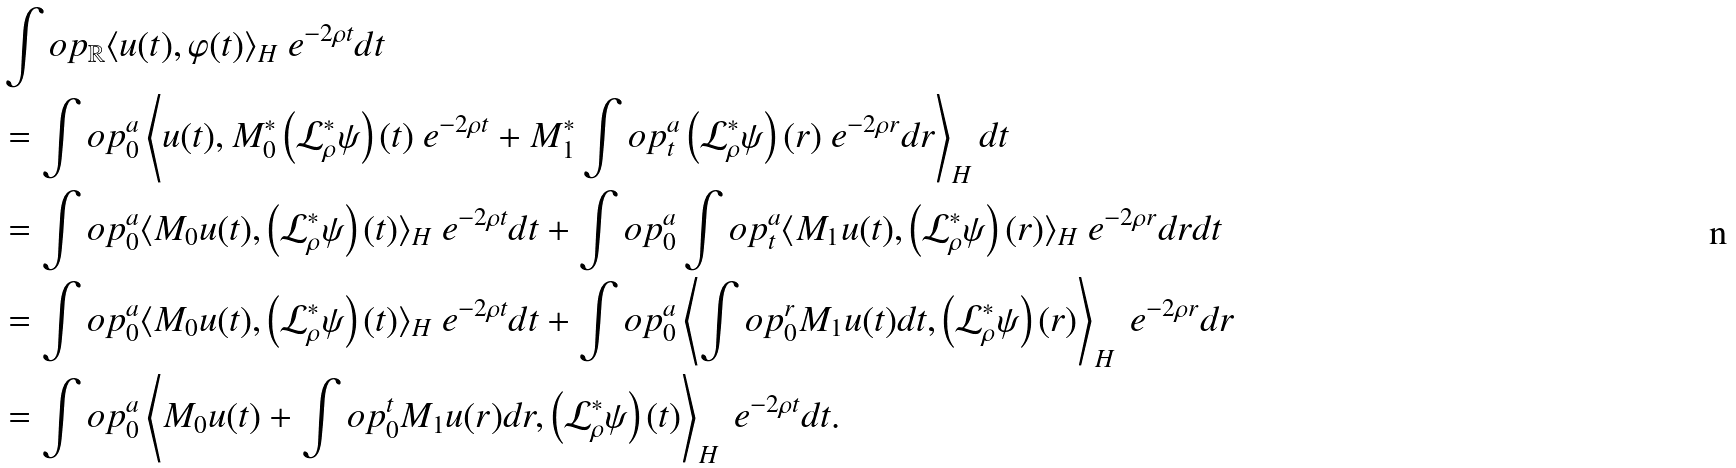Convert formula to latex. <formula><loc_0><loc_0><loc_500><loc_500>& \int o p _ { \mathbb { R } } \langle u ( t ) , \varphi ( t ) \rangle _ { H } \ e ^ { - 2 \rho t } d t \\ & = \int o p _ { 0 } ^ { a } \left \langle u ( t ) , M _ { 0 } ^ { \ast } \left ( \mathcal { L } _ { \rho } ^ { \ast } \psi \right ) ( t ) \ e ^ { - 2 \rho t } + M _ { 1 } ^ { \ast } \int o p _ { t } ^ { a } \left ( \mathcal { L } _ { \rho } ^ { \ast } \psi \right ) ( r ) \ e ^ { - 2 \rho r } d r \right \rangle _ { H } d t \\ & = \int o p _ { 0 } ^ { a } \langle M _ { 0 } u ( t ) , \left ( \mathcal { L } _ { \rho } ^ { \ast } \psi \right ) ( t ) \rangle _ { H } \ e ^ { - 2 \rho t } d t + \int o p _ { 0 } ^ { a } \int o p _ { t } ^ { a } \langle M _ { 1 } u ( t ) , \left ( \mathcal { L } _ { \rho } ^ { \ast } \psi \right ) ( r ) \rangle _ { H } \ e ^ { - 2 \rho r } d r d t \\ & = \int o p _ { 0 } ^ { a } \langle M _ { 0 } u ( t ) , \left ( \mathcal { L } _ { \rho } ^ { \ast } \psi \right ) ( t ) \rangle _ { H } \ e ^ { - 2 \rho t } d t + \int o p _ { 0 } ^ { a } \left \langle \int o p _ { 0 } ^ { r } M _ { 1 } u ( t ) d t , \left ( \mathcal { L } _ { \rho } ^ { \ast } \psi \right ) ( r ) \right \rangle _ { H } \ e ^ { - 2 \rho r } d r \\ & = \int o p _ { 0 } ^ { a } \left \langle M _ { 0 } u ( t ) + \int o p _ { 0 } ^ { t } M _ { 1 } u ( r ) d r , \left ( \mathcal { L } _ { \rho } ^ { \ast } \psi \right ) ( t ) \right \rangle _ { H } \ e ^ { - 2 \rho t } d t .</formula> 